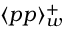Convert formula to latex. <formula><loc_0><loc_0><loc_500><loc_500>\langle p p \rangle _ { w } ^ { + }</formula> 